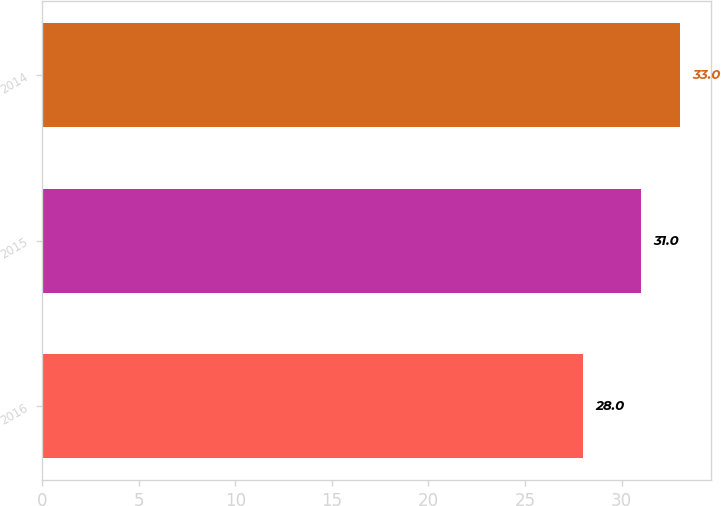<chart> <loc_0><loc_0><loc_500><loc_500><bar_chart><fcel>2016<fcel>2015<fcel>2014<nl><fcel>28<fcel>31<fcel>33<nl></chart> 